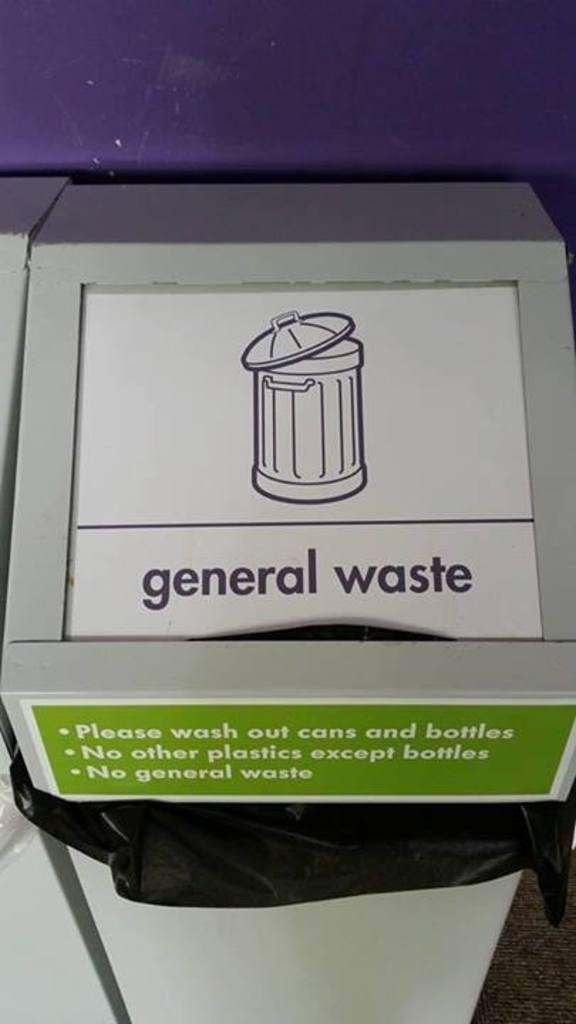What is the main object in the center of the image? There is a dustbin in the center of the image. What can be seen in the background of the image? There is a wall in the background of the image. How many stars can be seen on the dustbin in the image? There are no stars visible on the dustbin in the image. What type of bomb is present in the image? There is no bomb present in the image; it only features a dustbin and a wall in the background. 